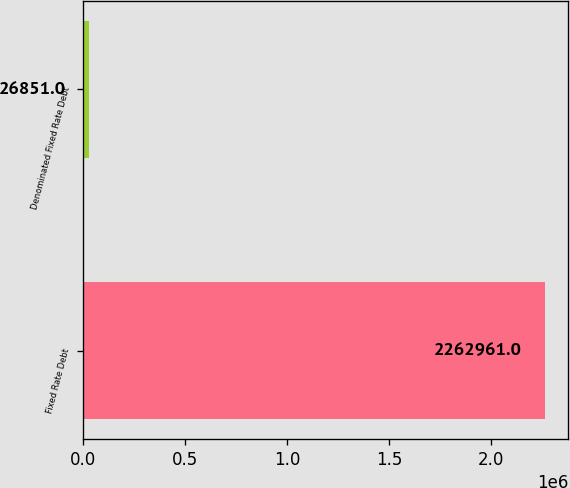Convert chart. <chart><loc_0><loc_0><loc_500><loc_500><bar_chart><fcel>Fixed Rate Debt<fcel>Denominated Fixed Rate Debt<nl><fcel>2.26296e+06<fcel>26851<nl></chart> 